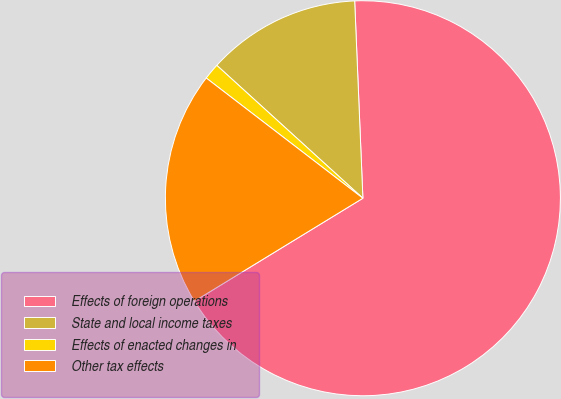Convert chart to OTSL. <chart><loc_0><loc_0><loc_500><loc_500><pie_chart><fcel>Effects of foreign operations<fcel>State and local income taxes<fcel>Effects of enacted changes in<fcel>Other tax effects<nl><fcel>66.93%<fcel>12.59%<fcel>1.33%<fcel>19.15%<nl></chart> 